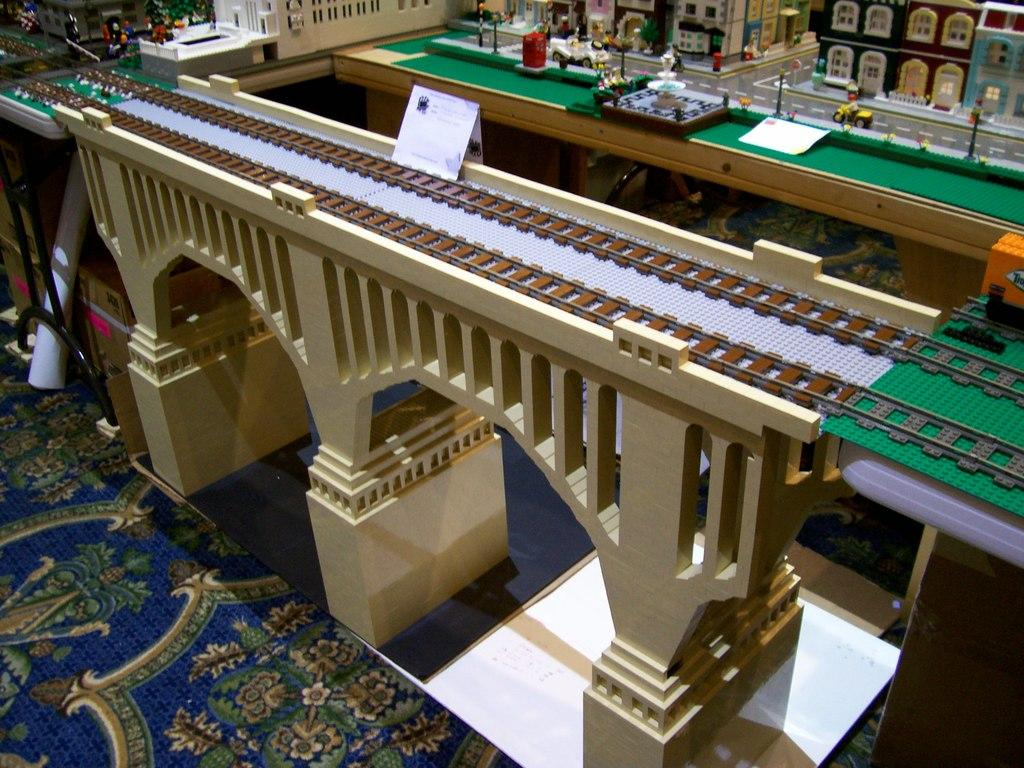What type of structure is depicted in miniature form in the image? There is a miniature of a bridge, a railway track, a fountain, and buildings in the image. What features can be seen in the miniature buildings? The miniature buildings have windows. What mode of transportation is present in the image? There are vehicles in the image. What other objects can be seen on the surface in the image? There are poles and other objects in the image. What type of parent is shown interacting with the children at the playground in the image? There is no playground or parent present in the image; it features miniature structures and objects. What type of carpentry work is being done by the carpenter in the image? There is no carpenter or carpentry work present in the image; it features miniature structures and objects. 